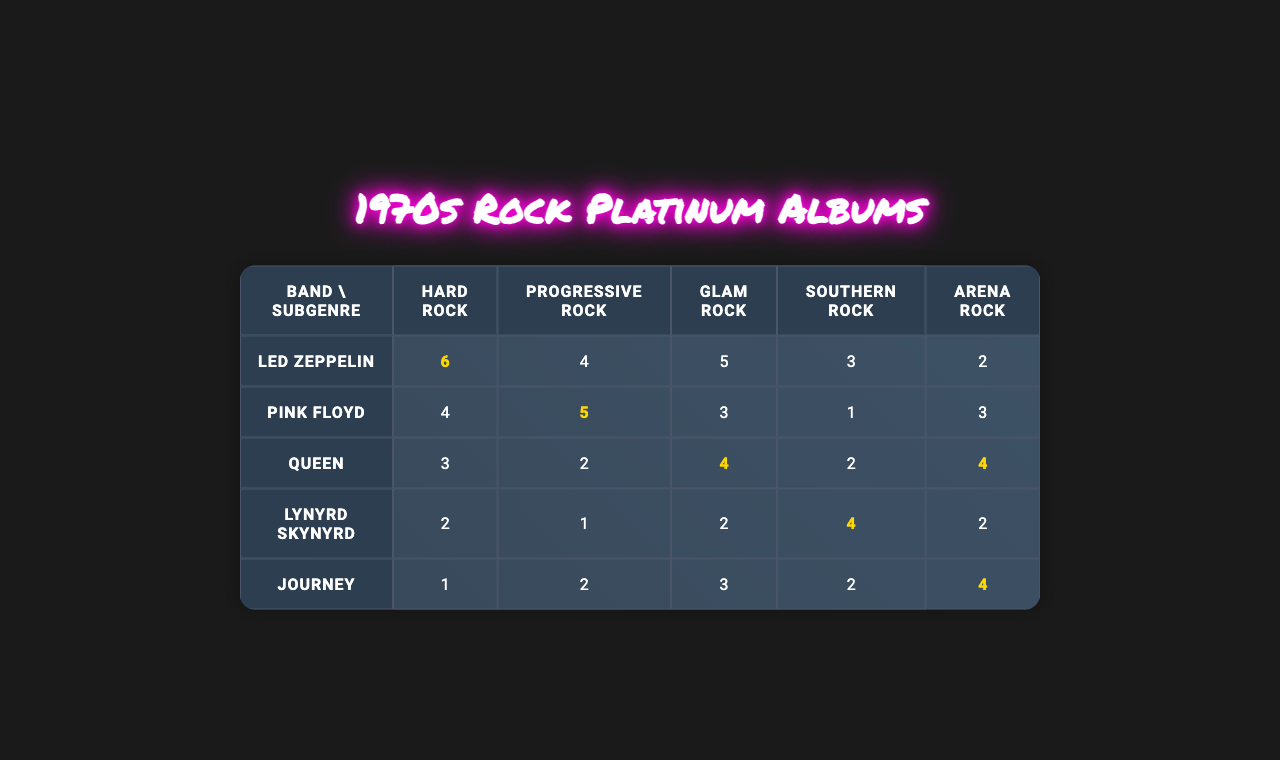What rock band has the most platinum albums in Hard Rock? By looking at the Hard Rock column, Led Zeppelin has the most platinum albums with a total of 6.
Answer: Led Zeppelin Which subgenre has the fewest total platinum albums across all bands? To find this, we sum the platinum albums for each subgenre: Hard Rock (16), Progressive Rock (15), Glam Rock (15), Southern Rock (10), Arena Rock (15). Southern Rock has the least with 10 albums.
Answer: Southern Rock What is the total number of platinum albums by Queen? Queen's total can be found by adding the platinum albums across all subgenres they are in: Hard Rock (3), Progressive Rock (2), Glam Rock (4), Southern Rock (2), Arena Rock (4), which gives 3 + 2 + 4 + 2 + 4 = 15.
Answer: 15 Which band has the highest number of platinum albums in Arena Rock? Referring to the Arena Rock column, Journey has the highest number with 4 platinum albums, compared to the others: Led Zeppelin (2), Pink Floyd (3), Queen (4), Lynyrd Skynyrd (2).
Answer: Journey & Queen What is the average number of platinum albums for Progressive Rock? We find the totals for each band in the Progressive Rock column: Led Zeppelin (4), Pink Floyd (5), Queen (2), Lynyrd Skynyrd (1), Journey (2). The total is 4 + 5 + 2 + 1 + 2 = 14. There are 5 bands, so the average is 14 / 5 = 2.8.
Answer: 2.8 Which band has the least number of platinum albums in Southern Rock? The Southern Rock column shows Lynyrd Skynyrd with 4 platinum albums, followed by others: Led Zeppelin (3), Pink Floyd (1), Queen (2), Journey (2). Lynyrd Skynyrd has the most so we'll check the others and confirm Pink Floyd has the least with just 1 album.
Answer: Pink Floyd Is it true that the number of platinum albums for Glam Rock is higher than in Southern Rock? We compare both columns: Glam Rock totals 13 (3 + 4 + 2 + 2 + 3), while Southern Rock totals 10. Since 13 is greater than 10, the statement is true.
Answer: Yes What is the difference in the number of platinum albums for Led Zeppelin between Hard Rock and Progressive Rock? We have 6 platinum albums in Hard Rock and 4 in Progressive Rock. The difference is calculated by subtracting: 6 - 4 = 2.
Answer: 2 Which subgenre has more total platinum albums: Glam Rock or Arena Rock? Adding Glam Rock gives us 15 (3 + 4 + 2 + 2 + 4), while Arena Rock has 15 as well (2 + 3 + 4 + 2 + 4). Both subgenres have the same total, hence Glam Rock does not have more than Arena Rock.
Answer: No difference 